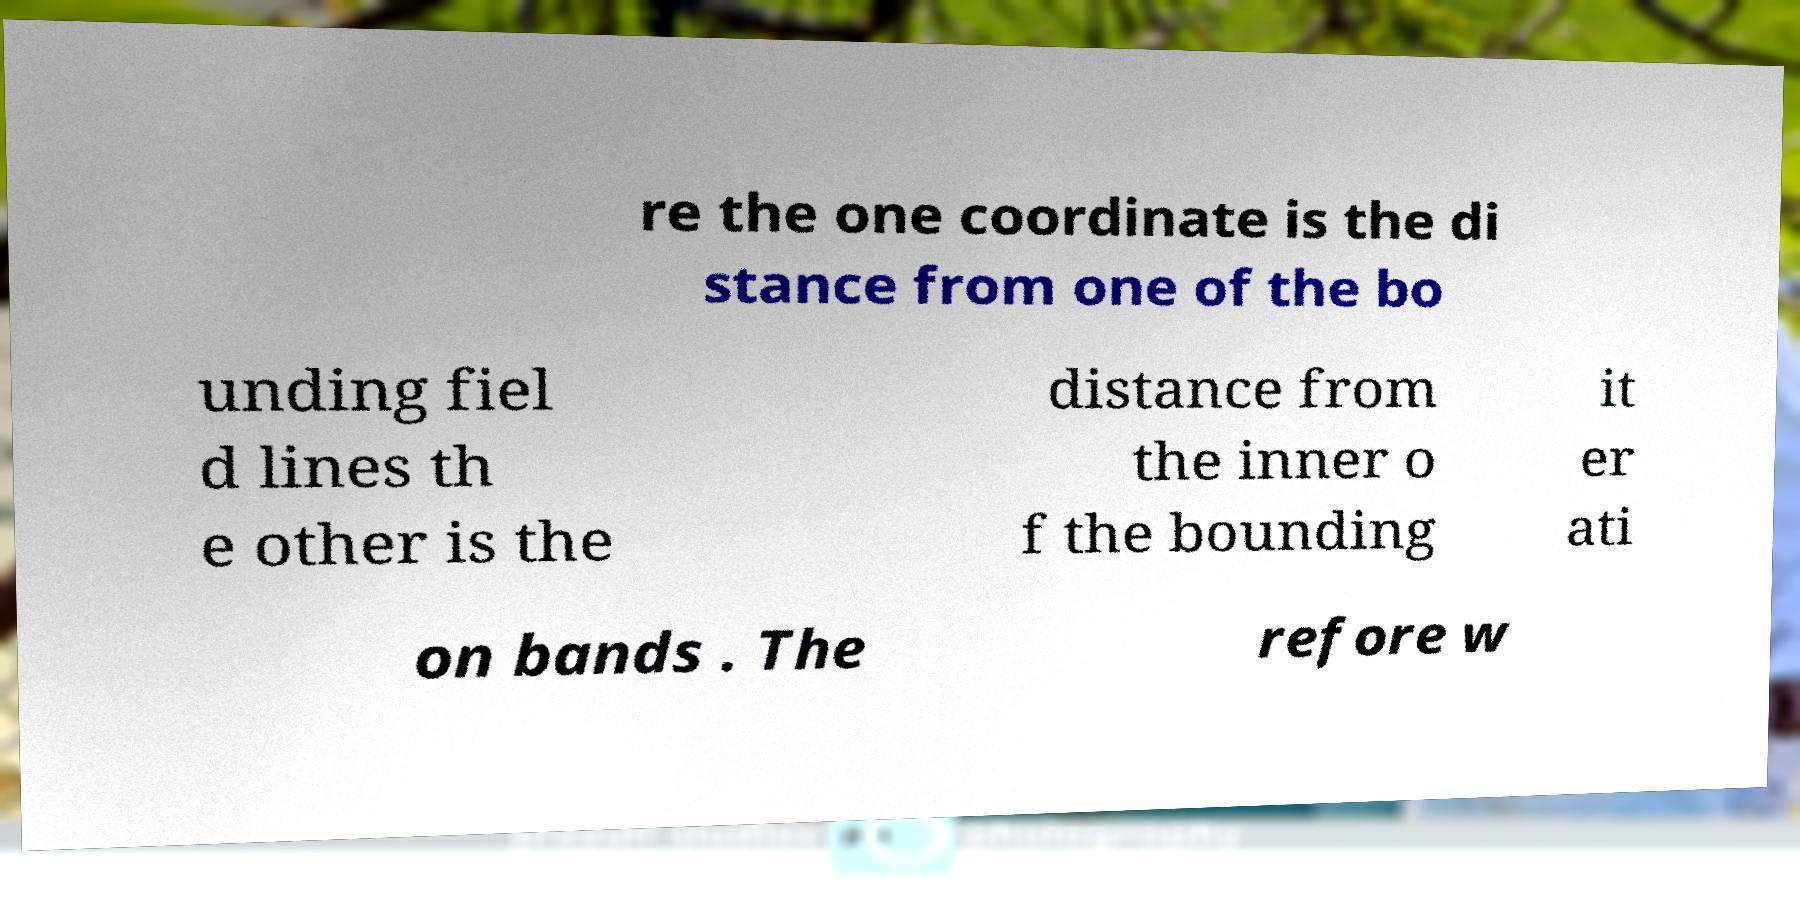Could you assist in decoding the text presented in this image and type it out clearly? re the one coordinate is the di stance from one of the bo unding fiel d lines th e other is the distance from the inner o f the bounding it er ati on bands . The refore w 